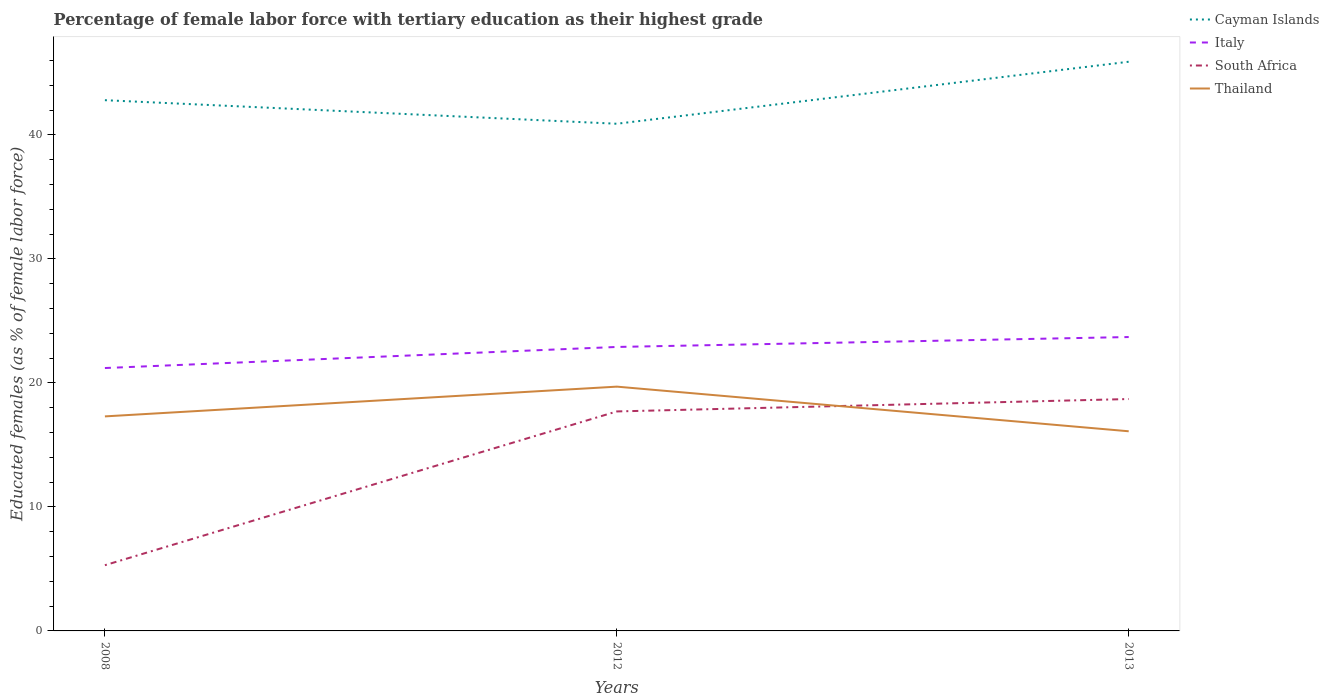How many different coloured lines are there?
Keep it short and to the point. 4. Does the line corresponding to Thailand intersect with the line corresponding to Cayman Islands?
Keep it short and to the point. No. Across all years, what is the maximum percentage of female labor force with tertiary education in South Africa?
Your answer should be very brief. 5.3. What is the total percentage of female labor force with tertiary education in South Africa in the graph?
Offer a very short reply. -12.4. What is the difference between the highest and the second highest percentage of female labor force with tertiary education in South Africa?
Provide a succinct answer. 13.4. How many lines are there?
Provide a short and direct response. 4. Are the values on the major ticks of Y-axis written in scientific E-notation?
Your answer should be compact. No. How many legend labels are there?
Your response must be concise. 4. What is the title of the graph?
Offer a terse response. Percentage of female labor force with tertiary education as their highest grade. Does "Channel Islands" appear as one of the legend labels in the graph?
Your answer should be very brief. No. What is the label or title of the X-axis?
Make the answer very short. Years. What is the label or title of the Y-axis?
Provide a succinct answer. Educated females (as % of female labor force). What is the Educated females (as % of female labor force) of Cayman Islands in 2008?
Ensure brevity in your answer.  42.8. What is the Educated females (as % of female labor force) in Italy in 2008?
Make the answer very short. 21.2. What is the Educated females (as % of female labor force) in South Africa in 2008?
Provide a succinct answer. 5.3. What is the Educated females (as % of female labor force) of Thailand in 2008?
Your answer should be very brief. 17.3. What is the Educated females (as % of female labor force) of Cayman Islands in 2012?
Make the answer very short. 40.9. What is the Educated females (as % of female labor force) of Italy in 2012?
Keep it short and to the point. 22.9. What is the Educated females (as % of female labor force) in South Africa in 2012?
Ensure brevity in your answer.  17.7. What is the Educated females (as % of female labor force) in Thailand in 2012?
Your answer should be very brief. 19.7. What is the Educated females (as % of female labor force) of Cayman Islands in 2013?
Offer a terse response. 45.9. What is the Educated females (as % of female labor force) in Italy in 2013?
Your answer should be very brief. 23.7. What is the Educated females (as % of female labor force) in South Africa in 2013?
Your answer should be compact. 18.7. What is the Educated females (as % of female labor force) in Thailand in 2013?
Make the answer very short. 16.1. Across all years, what is the maximum Educated females (as % of female labor force) in Cayman Islands?
Offer a terse response. 45.9. Across all years, what is the maximum Educated females (as % of female labor force) in Italy?
Provide a short and direct response. 23.7. Across all years, what is the maximum Educated females (as % of female labor force) of South Africa?
Your response must be concise. 18.7. Across all years, what is the maximum Educated females (as % of female labor force) in Thailand?
Offer a terse response. 19.7. Across all years, what is the minimum Educated females (as % of female labor force) of Cayman Islands?
Your answer should be compact. 40.9. Across all years, what is the minimum Educated females (as % of female labor force) of Italy?
Give a very brief answer. 21.2. Across all years, what is the minimum Educated females (as % of female labor force) in South Africa?
Provide a succinct answer. 5.3. Across all years, what is the minimum Educated females (as % of female labor force) of Thailand?
Give a very brief answer. 16.1. What is the total Educated females (as % of female labor force) of Cayman Islands in the graph?
Offer a terse response. 129.6. What is the total Educated females (as % of female labor force) of Italy in the graph?
Your answer should be very brief. 67.8. What is the total Educated females (as % of female labor force) of South Africa in the graph?
Provide a short and direct response. 41.7. What is the total Educated females (as % of female labor force) of Thailand in the graph?
Keep it short and to the point. 53.1. What is the difference between the Educated females (as % of female labor force) of Italy in 2008 and that in 2012?
Your answer should be compact. -1.7. What is the difference between the Educated females (as % of female labor force) in South Africa in 2008 and that in 2012?
Give a very brief answer. -12.4. What is the difference between the Educated females (as % of female labor force) in South Africa in 2008 and that in 2013?
Make the answer very short. -13.4. What is the difference between the Educated females (as % of female labor force) in Cayman Islands in 2012 and that in 2013?
Your answer should be compact. -5. What is the difference between the Educated females (as % of female labor force) in Italy in 2012 and that in 2013?
Your answer should be compact. -0.8. What is the difference between the Educated females (as % of female labor force) of Cayman Islands in 2008 and the Educated females (as % of female labor force) of South Africa in 2012?
Ensure brevity in your answer.  25.1. What is the difference between the Educated females (as % of female labor force) in Cayman Islands in 2008 and the Educated females (as % of female labor force) in Thailand in 2012?
Give a very brief answer. 23.1. What is the difference between the Educated females (as % of female labor force) of Italy in 2008 and the Educated females (as % of female labor force) of Thailand in 2012?
Give a very brief answer. 1.5. What is the difference between the Educated females (as % of female labor force) in South Africa in 2008 and the Educated females (as % of female labor force) in Thailand in 2012?
Ensure brevity in your answer.  -14.4. What is the difference between the Educated females (as % of female labor force) in Cayman Islands in 2008 and the Educated females (as % of female labor force) in South Africa in 2013?
Provide a short and direct response. 24.1. What is the difference between the Educated females (as % of female labor force) of Cayman Islands in 2008 and the Educated females (as % of female labor force) of Thailand in 2013?
Keep it short and to the point. 26.7. What is the difference between the Educated females (as % of female labor force) in Italy in 2008 and the Educated females (as % of female labor force) in Thailand in 2013?
Provide a succinct answer. 5.1. What is the difference between the Educated females (as % of female labor force) in South Africa in 2008 and the Educated females (as % of female labor force) in Thailand in 2013?
Offer a terse response. -10.8. What is the difference between the Educated females (as % of female labor force) in Cayman Islands in 2012 and the Educated females (as % of female labor force) in Italy in 2013?
Ensure brevity in your answer.  17.2. What is the difference between the Educated females (as % of female labor force) of Cayman Islands in 2012 and the Educated females (as % of female labor force) of South Africa in 2013?
Your response must be concise. 22.2. What is the difference between the Educated females (as % of female labor force) in Cayman Islands in 2012 and the Educated females (as % of female labor force) in Thailand in 2013?
Keep it short and to the point. 24.8. What is the difference between the Educated females (as % of female labor force) of Italy in 2012 and the Educated females (as % of female labor force) of South Africa in 2013?
Offer a very short reply. 4.2. What is the difference between the Educated females (as % of female labor force) of Italy in 2012 and the Educated females (as % of female labor force) of Thailand in 2013?
Provide a succinct answer. 6.8. What is the difference between the Educated females (as % of female labor force) in South Africa in 2012 and the Educated females (as % of female labor force) in Thailand in 2013?
Ensure brevity in your answer.  1.6. What is the average Educated females (as % of female labor force) of Cayman Islands per year?
Offer a very short reply. 43.2. What is the average Educated females (as % of female labor force) of Italy per year?
Provide a short and direct response. 22.6. What is the average Educated females (as % of female labor force) of South Africa per year?
Provide a short and direct response. 13.9. In the year 2008, what is the difference between the Educated females (as % of female labor force) in Cayman Islands and Educated females (as % of female labor force) in Italy?
Offer a very short reply. 21.6. In the year 2008, what is the difference between the Educated females (as % of female labor force) of Cayman Islands and Educated females (as % of female labor force) of South Africa?
Give a very brief answer. 37.5. In the year 2008, what is the difference between the Educated females (as % of female labor force) in Cayman Islands and Educated females (as % of female labor force) in Thailand?
Make the answer very short. 25.5. In the year 2008, what is the difference between the Educated females (as % of female labor force) of Italy and Educated females (as % of female labor force) of South Africa?
Your response must be concise. 15.9. In the year 2008, what is the difference between the Educated females (as % of female labor force) of South Africa and Educated females (as % of female labor force) of Thailand?
Offer a very short reply. -12. In the year 2012, what is the difference between the Educated females (as % of female labor force) of Cayman Islands and Educated females (as % of female labor force) of Italy?
Give a very brief answer. 18. In the year 2012, what is the difference between the Educated females (as % of female labor force) in Cayman Islands and Educated females (as % of female labor force) in South Africa?
Offer a very short reply. 23.2. In the year 2012, what is the difference between the Educated females (as % of female labor force) in Cayman Islands and Educated females (as % of female labor force) in Thailand?
Provide a short and direct response. 21.2. In the year 2012, what is the difference between the Educated females (as % of female labor force) of Italy and Educated females (as % of female labor force) of South Africa?
Provide a short and direct response. 5.2. In the year 2012, what is the difference between the Educated females (as % of female labor force) in South Africa and Educated females (as % of female labor force) in Thailand?
Ensure brevity in your answer.  -2. In the year 2013, what is the difference between the Educated females (as % of female labor force) in Cayman Islands and Educated females (as % of female labor force) in South Africa?
Your answer should be compact. 27.2. In the year 2013, what is the difference between the Educated females (as % of female labor force) of Cayman Islands and Educated females (as % of female labor force) of Thailand?
Provide a short and direct response. 29.8. In the year 2013, what is the difference between the Educated females (as % of female labor force) in Italy and Educated females (as % of female labor force) in Thailand?
Your answer should be compact. 7.6. What is the ratio of the Educated females (as % of female labor force) of Cayman Islands in 2008 to that in 2012?
Provide a short and direct response. 1.05. What is the ratio of the Educated females (as % of female labor force) in Italy in 2008 to that in 2012?
Keep it short and to the point. 0.93. What is the ratio of the Educated females (as % of female labor force) of South Africa in 2008 to that in 2012?
Keep it short and to the point. 0.3. What is the ratio of the Educated females (as % of female labor force) of Thailand in 2008 to that in 2012?
Offer a terse response. 0.88. What is the ratio of the Educated females (as % of female labor force) in Cayman Islands in 2008 to that in 2013?
Keep it short and to the point. 0.93. What is the ratio of the Educated females (as % of female labor force) in Italy in 2008 to that in 2013?
Provide a succinct answer. 0.89. What is the ratio of the Educated females (as % of female labor force) of South Africa in 2008 to that in 2013?
Keep it short and to the point. 0.28. What is the ratio of the Educated females (as % of female labor force) in Thailand in 2008 to that in 2013?
Offer a very short reply. 1.07. What is the ratio of the Educated females (as % of female labor force) in Cayman Islands in 2012 to that in 2013?
Make the answer very short. 0.89. What is the ratio of the Educated females (as % of female labor force) of Italy in 2012 to that in 2013?
Offer a terse response. 0.97. What is the ratio of the Educated females (as % of female labor force) in South Africa in 2012 to that in 2013?
Give a very brief answer. 0.95. What is the ratio of the Educated females (as % of female labor force) in Thailand in 2012 to that in 2013?
Provide a short and direct response. 1.22. What is the difference between the highest and the second highest Educated females (as % of female labor force) in Italy?
Provide a succinct answer. 0.8. What is the difference between the highest and the second highest Educated females (as % of female labor force) of Thailand?
Your response must be concise. 2.4. What is the difference between the highest and the lowest Educated females (as % of female labor force) of Thailand?
Your answer should be very brief. 3.6. 